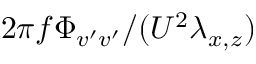<formula> <loc_0><loc_0><loc_500><loc_500>2 \pi f \Phi _ { v ^ { \prime } v ^ { \prime } } / ( U ^ { 2 } \lambda _ { x , z } )</formula> 